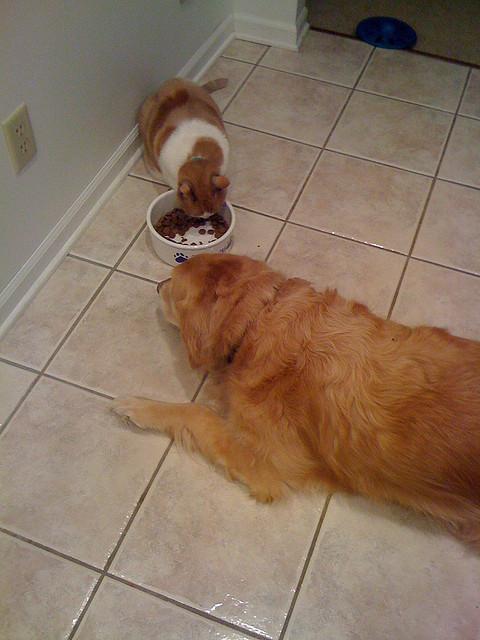How many red chairs can be seen?
Give a very brief answer. 0. 